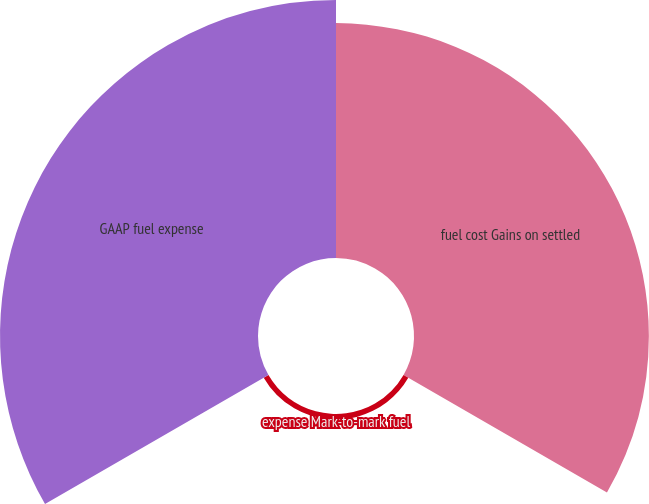<chart> <loc_0><loc_0><loc_500><loc_500><pie_chart><fcel>fuel cost Gains on settled<fcel>expense Mark-to-mark fuel<fcel>GAAP fuel expense<nl><fcel>47.13%<fcel>1.1%<fcel>51.77%<nl></chart> 